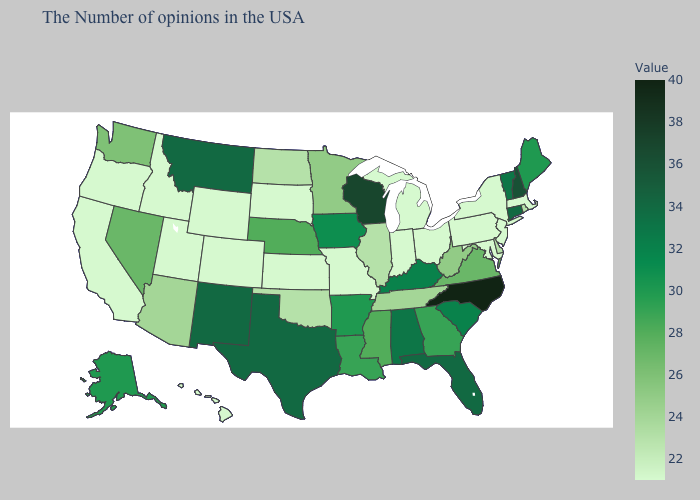Does Missouri have the lowest value in the USA?
Keep it brief. Yes. Does Missouri have the lowest value in the MidWest?
Answer briefly. Yes. Which states have the lowest value in the MidWest?
Keep it brief. Ohio, Michigan, Indiana, Missouri, Kansas, South Dakota. Among the states that border Utah , does Nevada have the highest value?
Quick response, please. No. Which states have the lowest value in the MidWest?
Concise answer only. Ohio, Michigan, Indiana, Missouri, Kansas, South Dakota. 